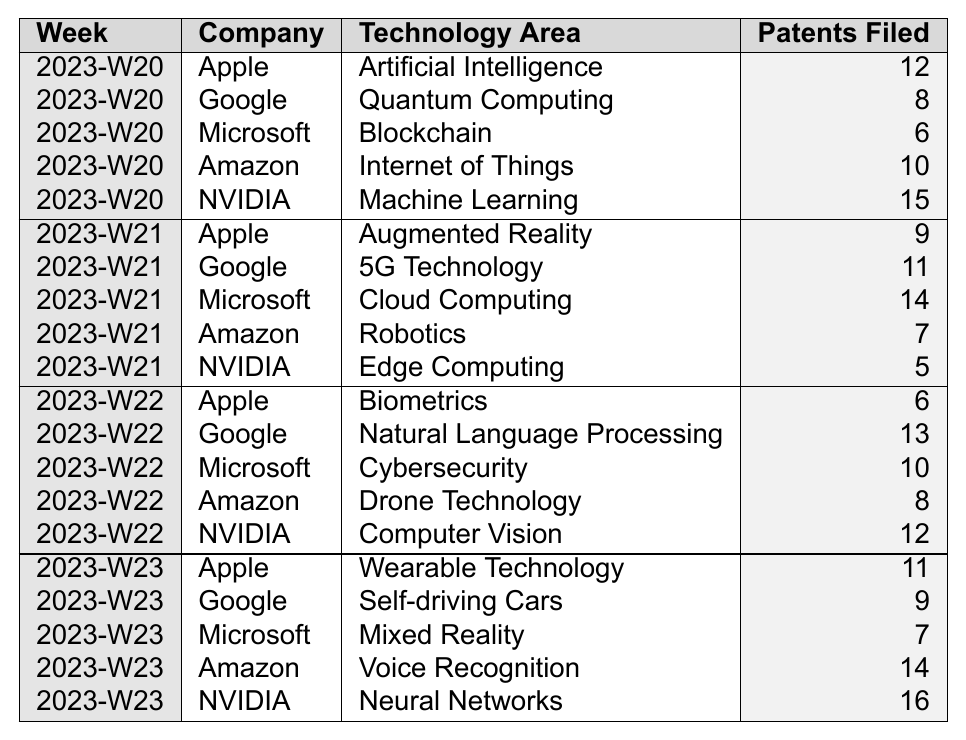What technology area had the highest number of patents filed by NVIDIA in Week 23? In Week 23, NVIDIA filed patents in "Neural Networks" and filed a total of 16 patents, which is the highest number compared to other technology areas in that week.
Answer: Neural Networks How many patents did Apple file across all weeks? Summing up Apple's patents: (12 + 9 + 6 + 11) = 38. Apple filed a total of 38 patents across all weeks.
Answer: 38 Which company filed the least number of patents in Week 20? In Week 20, Microsoft filed 6 patents, which is the lowest compared to the other companies in that week (Apple: 12, Google: 8, Amazon: 10, NVIDIA: 15).
Answer: Microsoft What is the average number of patents filed by Google over the four weeks? Summing up Google’s patents: (8 + 11 + 13 + 9) = 41. There are 4 weeks, so the average is 41/4 = 10.25.
Answer: 10.25 Did Amazon file more patents in Week 21 than in Week 20? In Week 20, Amazon filed 10 patents, and in Week 21, they filed 7 patents. Since 7 is less than 10, the answer is no.
Answer: No Which technology area did Microsoft focus on the most based on the number of patents filed in all weeks? By adding the patents filed by Microsoft: (6 + 14 + 10 + 7) = 37; they filed the most in "Cloud Computing" with 14 patents in Week 21, the highest individual count.
Answer: Cloud Computing What was the total number of patents filed in Week 22? Summing up the patents for all companies in Week 22: (6 + 13 + 10 + 8 + 12) = 49. The total number of patents filed in Week 22 was 49.
Answer: 49 Was there any week in which Apple filed more patents than NVIDIA? In Weeks 20, 21, and 22, training was noted that NVIDIA had more patents than Apple (15, 5, and 12 vs. 12, 9, and 6 respectively). In Week 23, NVIDIA had 16 patents, while Apple had 11; hence, Apple never outpaced NVIDIA.
Answer: No Which technology area received the most patents in Week 23? Analyzing Week 23: Amazon filed 14 patents (Voice Recognition), and NVIDIA filed 16 patents (Neural Networks). NVIDIA had the most patents filed in Week 23.
Answer: Neural Networks How many more patents did NVIDIA file compared to Apple in Week 20? In Week 20, NVIDIA filed 15 patents and Apple filed 12 patents, so the difference is 15 - 12 = 3. NVIDIA filed 3 more patents than Apple.
Answer: 3 Which company filed patents in the "Robotics" area and what was the count? In Week 21, Amazon filed patents in "Robotics", specifically 7 patents.
Answer: Amazon, 7 